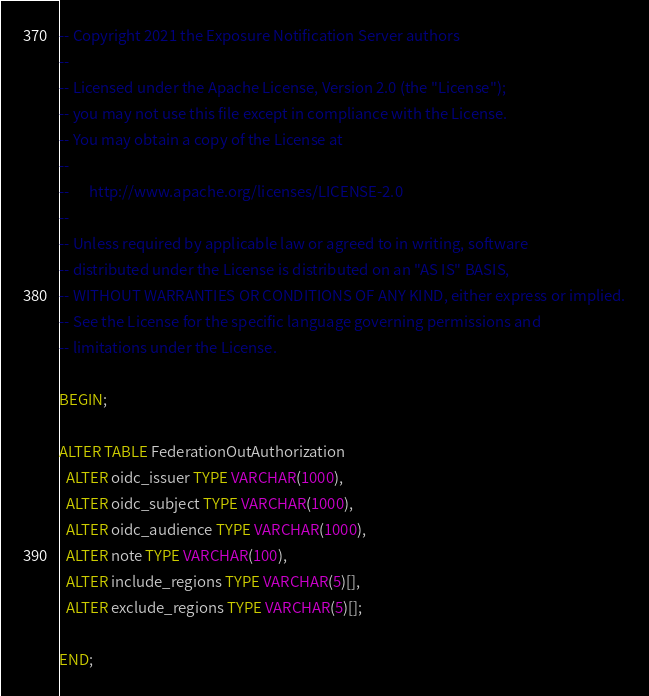Convert code to text. <code><loc_0><loc_0><loc_500><loc_500><_SQL_>-- Copyright 2021 the Exposure Notification Server authors
--
-- Licensed under the Apache License, Version 2.0 (the "License");
-- you may not use this file except in compliance with the License.
-- You may obtain a copy of the License at
--
--      http://www.apache.org/licenses/LICENSE-2.0
--
-- Unless required by applicable law or agreed to in writing, software
-- distributed under the License is distributed on an "AS IS" BASIS,
-- WITHOUT WARRANTIES OR CONDITIONS OF ANY KIND, either express or implied.
-- See the License for the specific language governing permissions and
-- limitations under the License.

BEGIN;

ALTER TABLE FederationOutAuthorization
  ALTER oidc_issuer TYPE VARCHAR(1000),
  ALTER oidc_subject TYPE VARCHAR(1000),
  ALTER oidc_audience TYPE VARCHAR(1000),
  ALTER note TYPE VARCHAR(100),
  ALTER include_regions TYPE VARCHAR(5)[],
  ALTER exclude_regions TYPE VARCHAR(5)[];

END;
</code> 